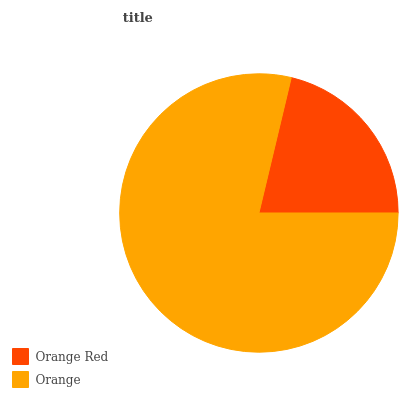Is Orange Red the minimum?
Answer yes or no. Yes. Is Orange the maximum?
Answer yes or no. Yes. Is Orange the minimum?
Answer yes or no. No. Is Orange greater than Orange Red?
Answer yes or no. Yes. Is Orange Red less than Orange?
Answer yes or no. Yes. Is Orange Red greater than Orange?
Answer yes or no. No. Is Orange less than Orange Red?
Answer yes or no. No. Is Orange the high median?
Answer yes or no. Yes. Is Orange Red the low median?
Answer yes or no. Yes. Is Orange Red the high median?
Answer yes or no. No. Is Orange the low median?
Answer yes or no. No. 